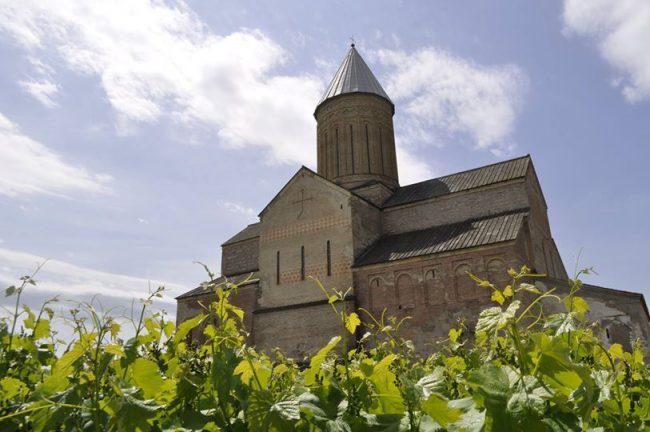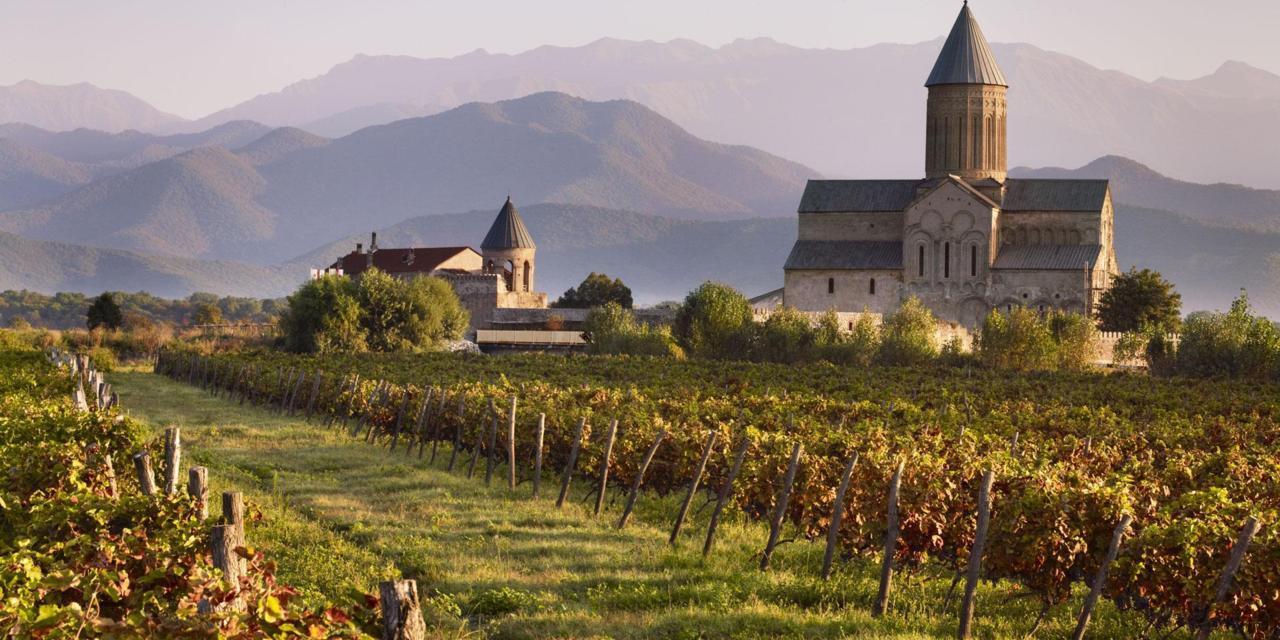The first image is the image on the left, the second image is the image on the right. Considering the images on both sides, is "In at least one image there are at least two triangle towers roofs behind a cobblestone wall." valid? Answer yes or no. No. The first image is the image on the left, the second image is the image on the right. For the images shown, is this caption "There is a stone wall in front of the building in one image, but no stone wall in front of the other." true? Answer yes or no. No. 